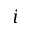<formula> <loc_0><loc_0><loc_500><loc_500>i</formula> 